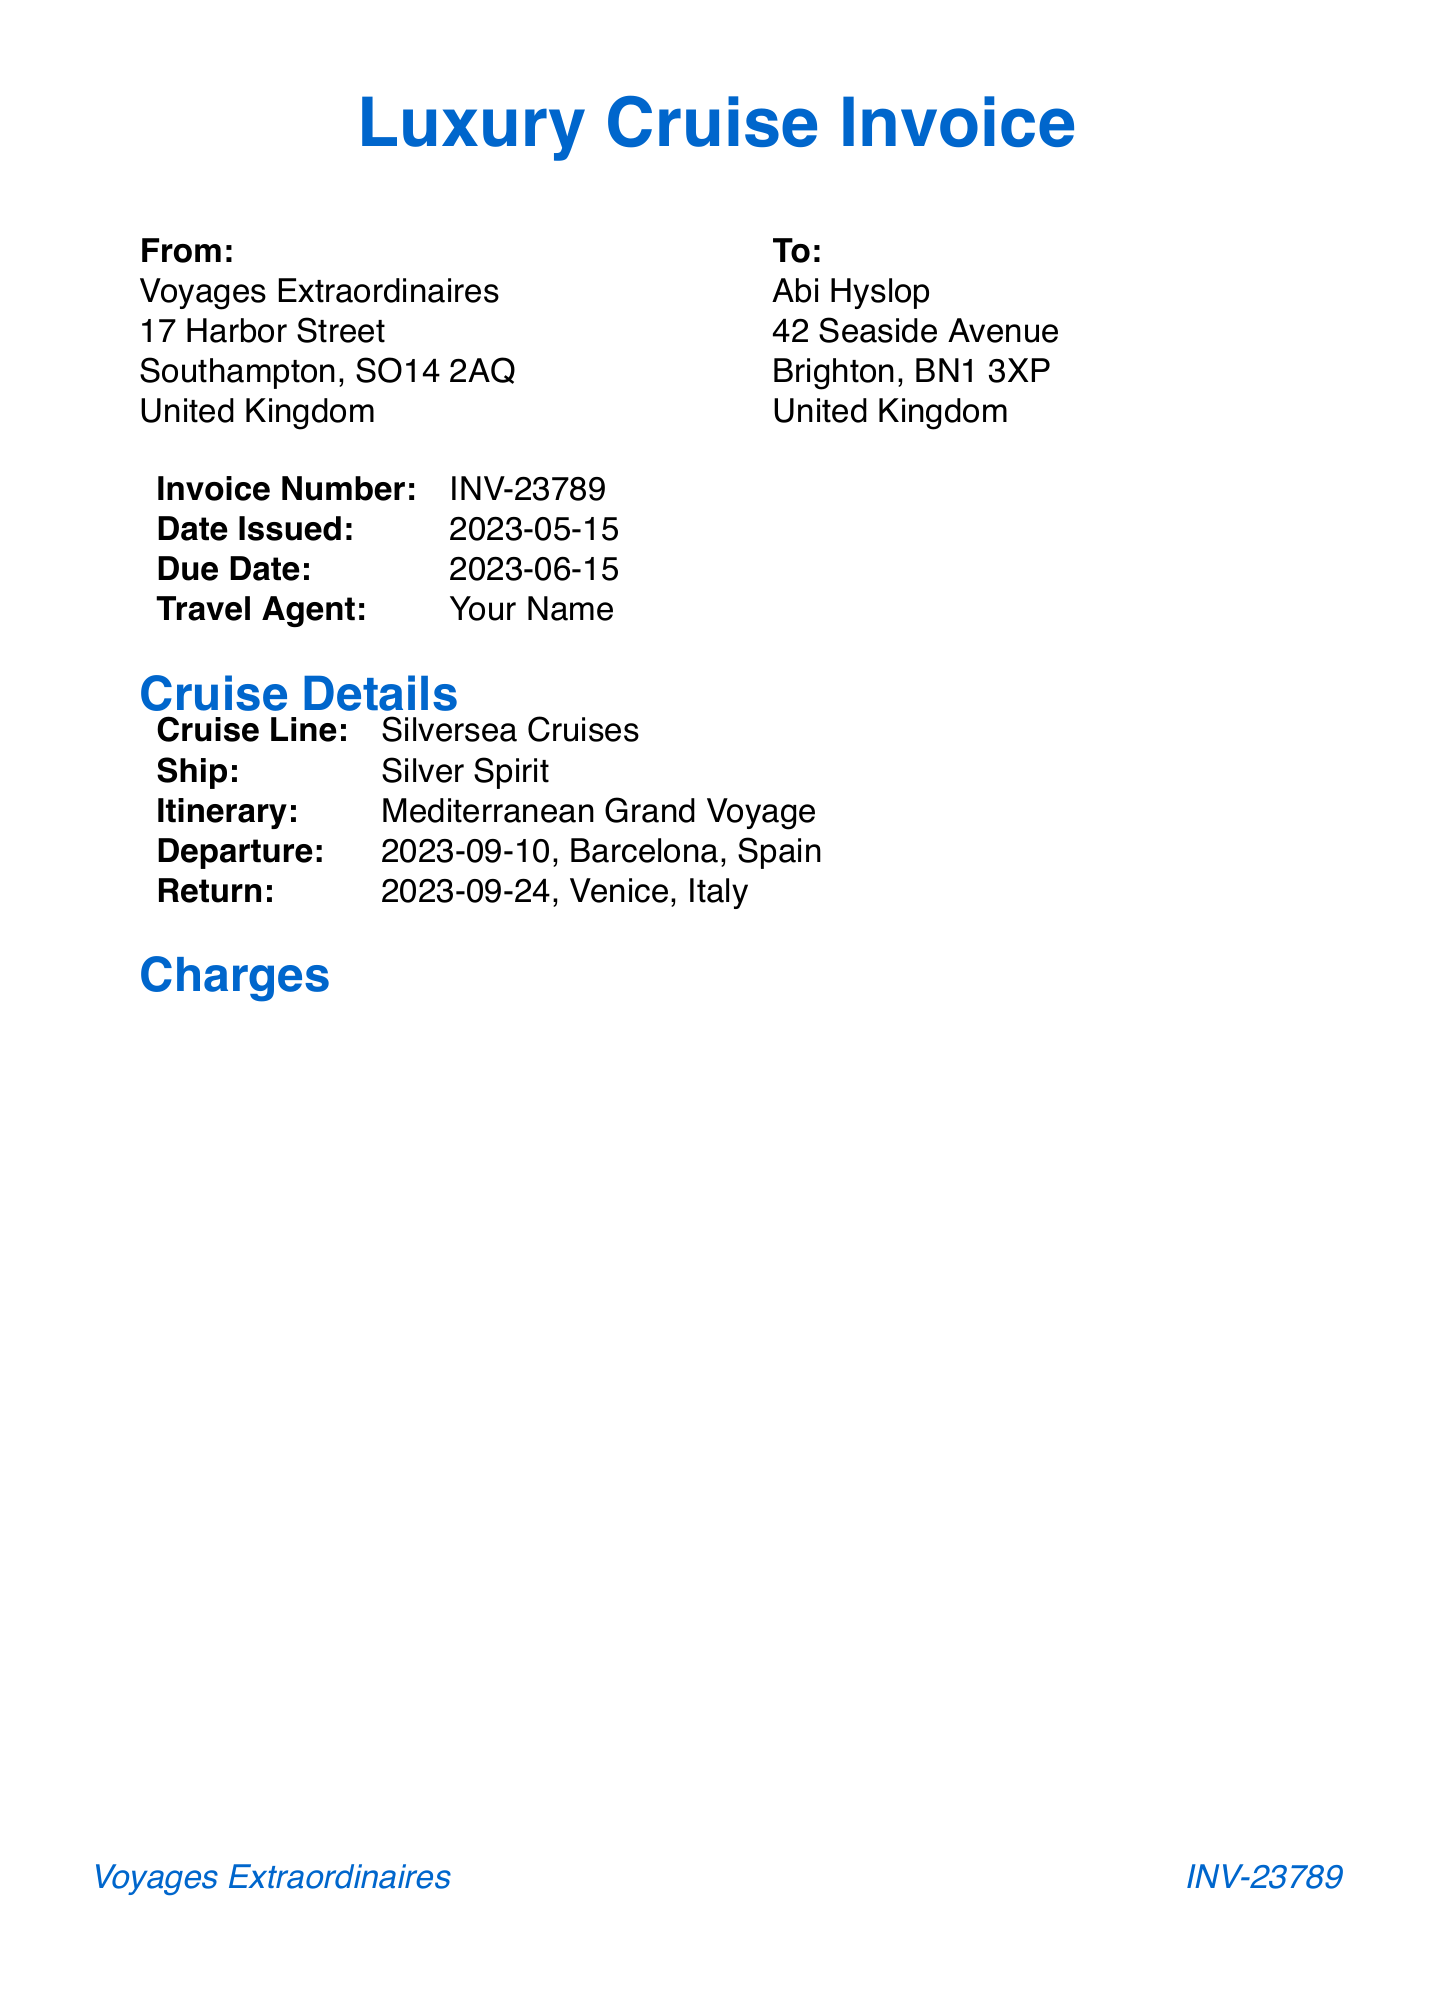What is the invoice number? The invoice number is clearly stated in the document as a key identifier for this invoice.
Answer: INV-23789 What is the total amount due? The total amount is calculated after all charges, discounts, and credits, which is indicated explicitly in the totals section of the invoice.
Answer: 14,635.00 Who is the client? The client name is specified at the top of the invoice to identify whom the invoice is for.
Answer: Abi Hyslop What luxury cruise line is featured in the invoice? The cruise line name can be found in the cruise details section, providing insight into the travel service.
Answer: Silversea Cruises What is the cancellation policy? The cancellation policy describes the terms for refunds and can be found in a dedicated section of the document.
Answer: 50% refund if cancelled 60 days before departure, no refund within 60 days How many shore excursions are included? The list of shore excursions is provided, and counting them gives the total number included.
Answer: 4 What is the address of the travel agency? The agency address is given in the invoice which identifies the travel service provider.
Answer: 17 Harbor Street, Southampton, SO14 2AQ, United Kingdom What is the due date for payment? The due date is clearly marked, indicating when the payment should be made to avoid penalties.
Answer: 2023-06-15 What is the description of the onboard credit? The onboard credit description provides insight into the source of the credit applied to the invoice total.
Answer: Loyalty program bonus 